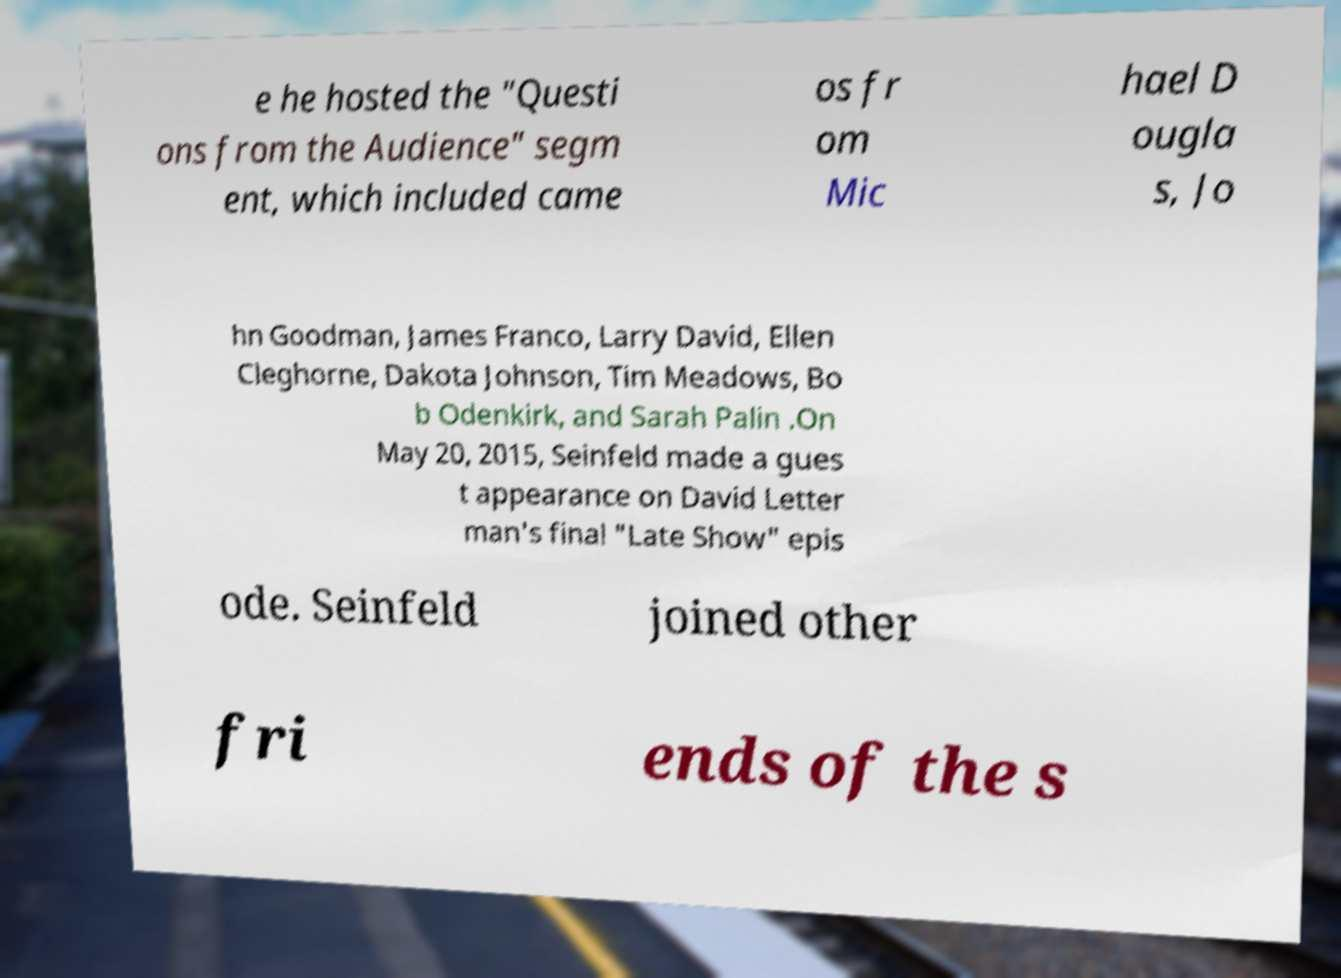Could you assist in decoding the text presented in this image and type it out clearly? e he hosted the "Questi ons from the Audience" segm ent, which included came os fr om Mic hael D ougla s, Jo hn Goodman, James Franco, Larry David, Ellen Cleghorne, Dakota Johnson, Tim Meadows, Bo b Odenkirk, and Sarah Palin .On May 20, 2015, Seinfeld made a gues t appearance on David Letter man's final "Late Show" epis ode. Seinfeld joined other fri ends of the s 